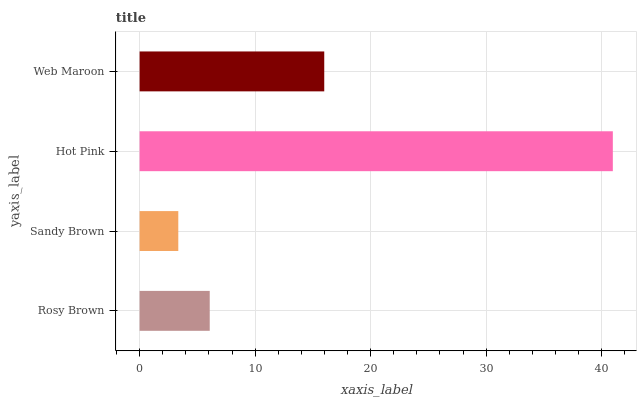Is Sandy Brown the minimum?
Answer yes or no. Yes. Is Hot Pink the maximum?
Answer yes or no. Yes. Is Hot Pink the minimum?
Answer yes or no. No. Is Sandy Brown the maximum?
Answer yes or no. No. Is Hot Pink greater than Sandy Brown?
Answer yes or no. Yes. Is Sandy Brown less than Hot Pink?
Answer yes or no. Yes. Is Sandy Brown greater than Hot Pink?
Answer yes or no. No. Is Hot Pink less than Sandy Brown?
Answer yes or no. No. Is Web Maroon the high median?
Answer yes or no. Yes. Is Rosy Brown the low median?
Answer yes or no. Yes. Is Sandy Brown the high median?
Answer yes or no. No. Is Hot Pink the low median?
Answer yes or no. No. 